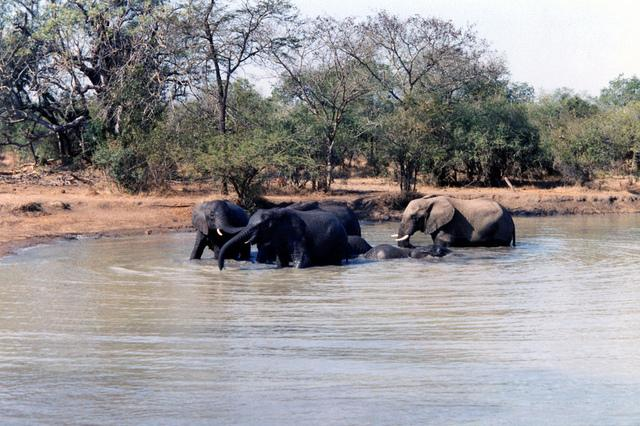What do the animals all have? trunks 